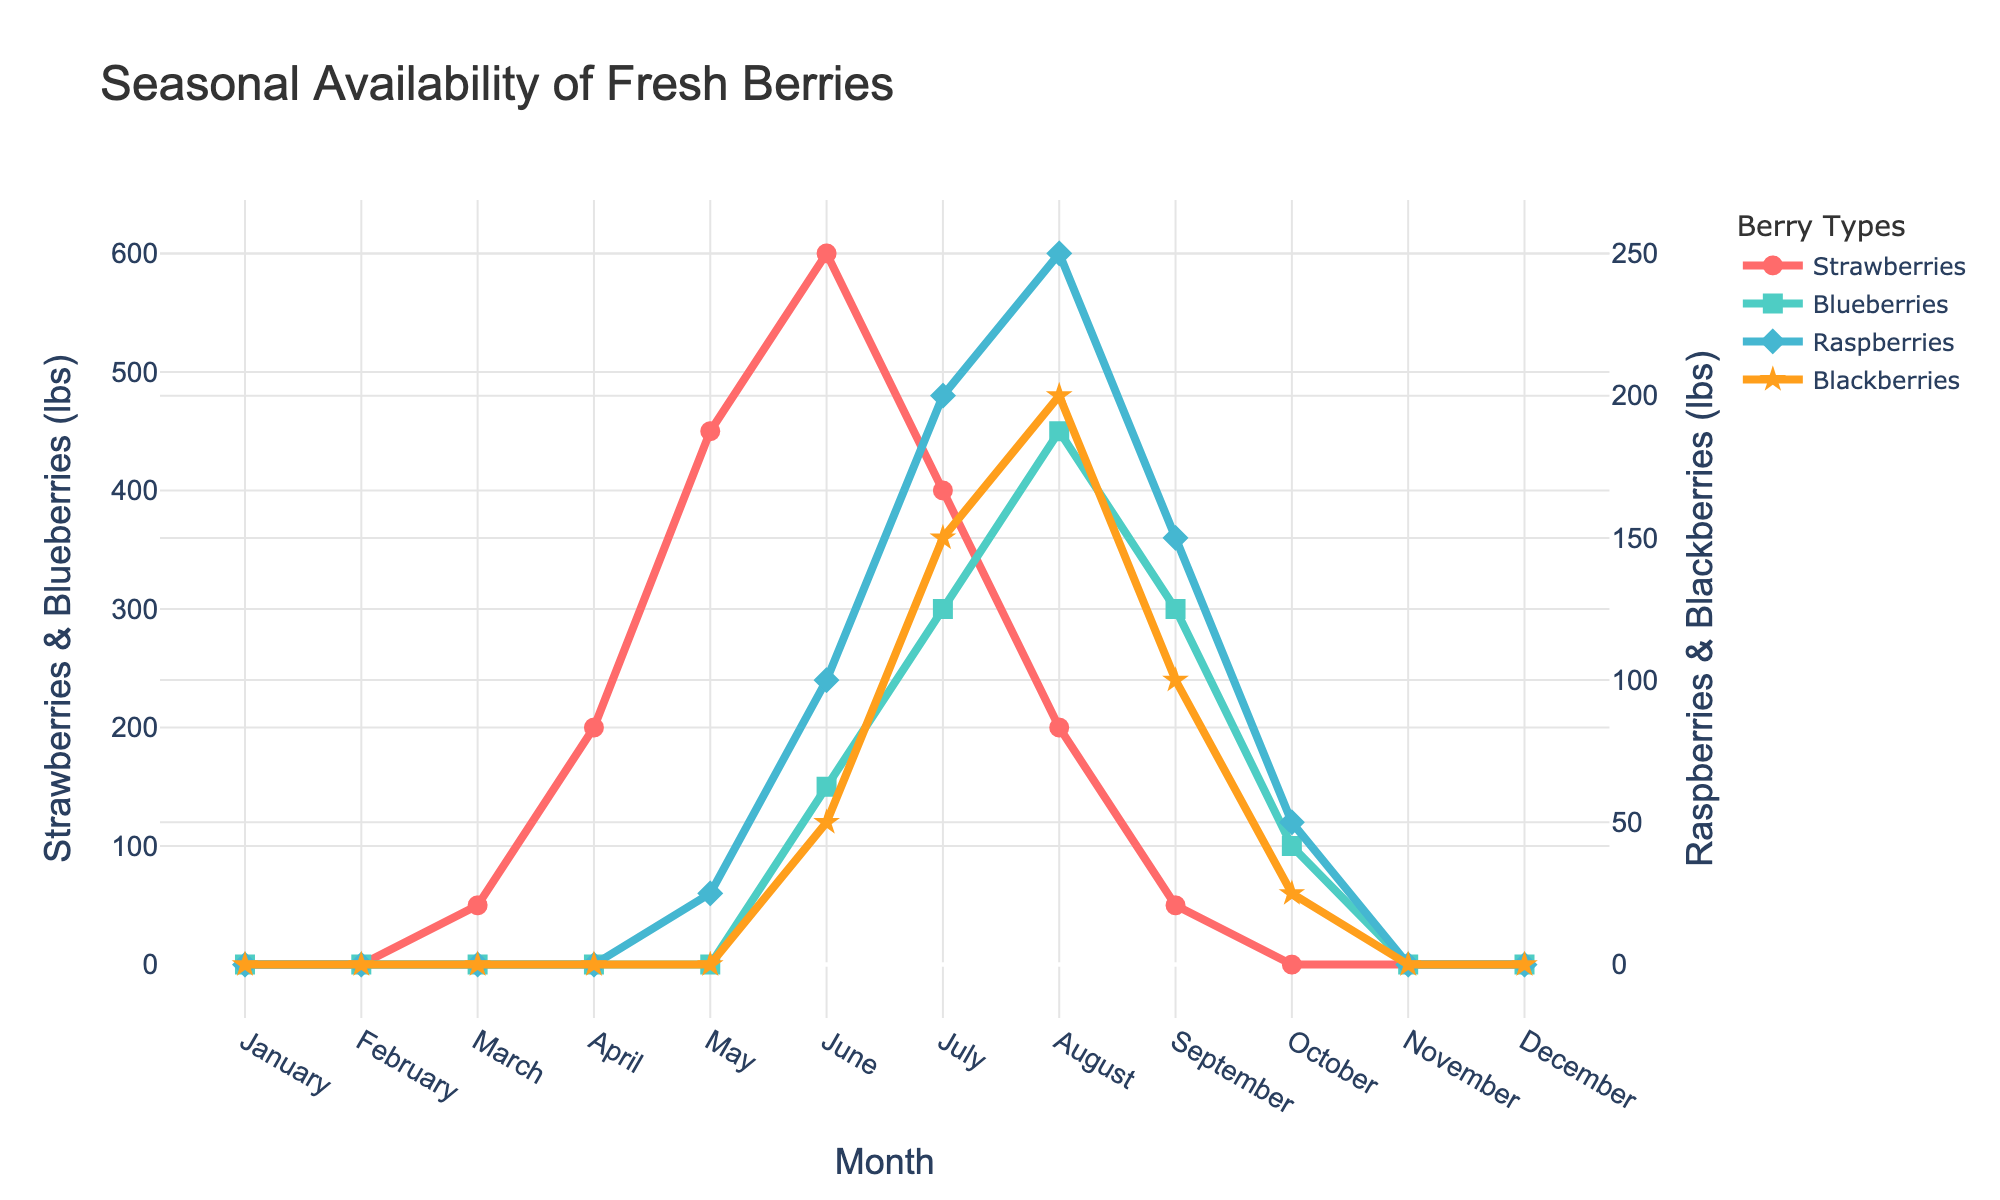What month has the highest availability of strawberries? By looking at the plot, identify the month with the highest peak for strawberries. This occurs in June with the highest value reaching 600 lbs.
Answer: June During which months are no fresh berries available at all? Check for the months where all lines are at zero. These months are January, February, November, and December.
Answer: January, February, November, December How does the availability of blueberries in July compare to that of raspberries and blackberries in the same month? In July, the blueberries line is at 300 lbs. For raspberries, the value is 200 lbs, and for blackberries, it is 150 lbs. Blueberries have higher availability compared to both raspberries and blackberries in July.
Answer: Higher What's the difference in the availability of strawberries between June and August? In June, strawberries are available at 600 lbs and in August at 200 lbs. The difference can be calculated as 600 - 200 = 400 lbs.
Answer: 400 lbs Which type of berry has the most extended availability throughout the year? Look at the lines for each berry to see which one spans the most months. Strawberries and blueberries are available from March to October, that's an 8-month span for strawberries and an 8-month span for blueberries. For raspberries and blackberries, the availability spans fewer months, from May to October which is 6 months.
Answer: Strawberries, Blueberries When do blackberries first become available and when do they peak? Blackberries first appear in June with 50 lbs and peak in August with 200 lbs.
Answer: June (start), August (peak) What is the combined availability of all berries in July? Sum the quantities for each berry in July: Strawberries (400 lbs), Blueberries (300 lbs), Raspberries (200 lbs), and Blackberries (150 lbs). The total is 400 + 300 + 200 + 150 = 1050 lbs.
Answer: 1050 lbs Compare the availability of raspberries in September and October. Are there any notable trends? In September, raspberries' availability is 150 lbs, while in October, it drops to 50 lbs. There is a noticeable decrease from September to October.
Answer: Decrease Which three months see the highest combined availability of all berries? Calculate the combined availability for each month and identify the top three months. June (900 lbs), July (1050 lbs), and August (1100 lbs) have the highest combined availability.
Answer: June, July, August During which month is the difference between the availability of raspberries and blueberries the greatest? Subtract the monthly values of raspberries from blueberries to see the differences. The greatest difference is in June where blueberries are 150 lbs and raspberries are 100 lbs, giving a difference of 50 lbs.
Answer: June 